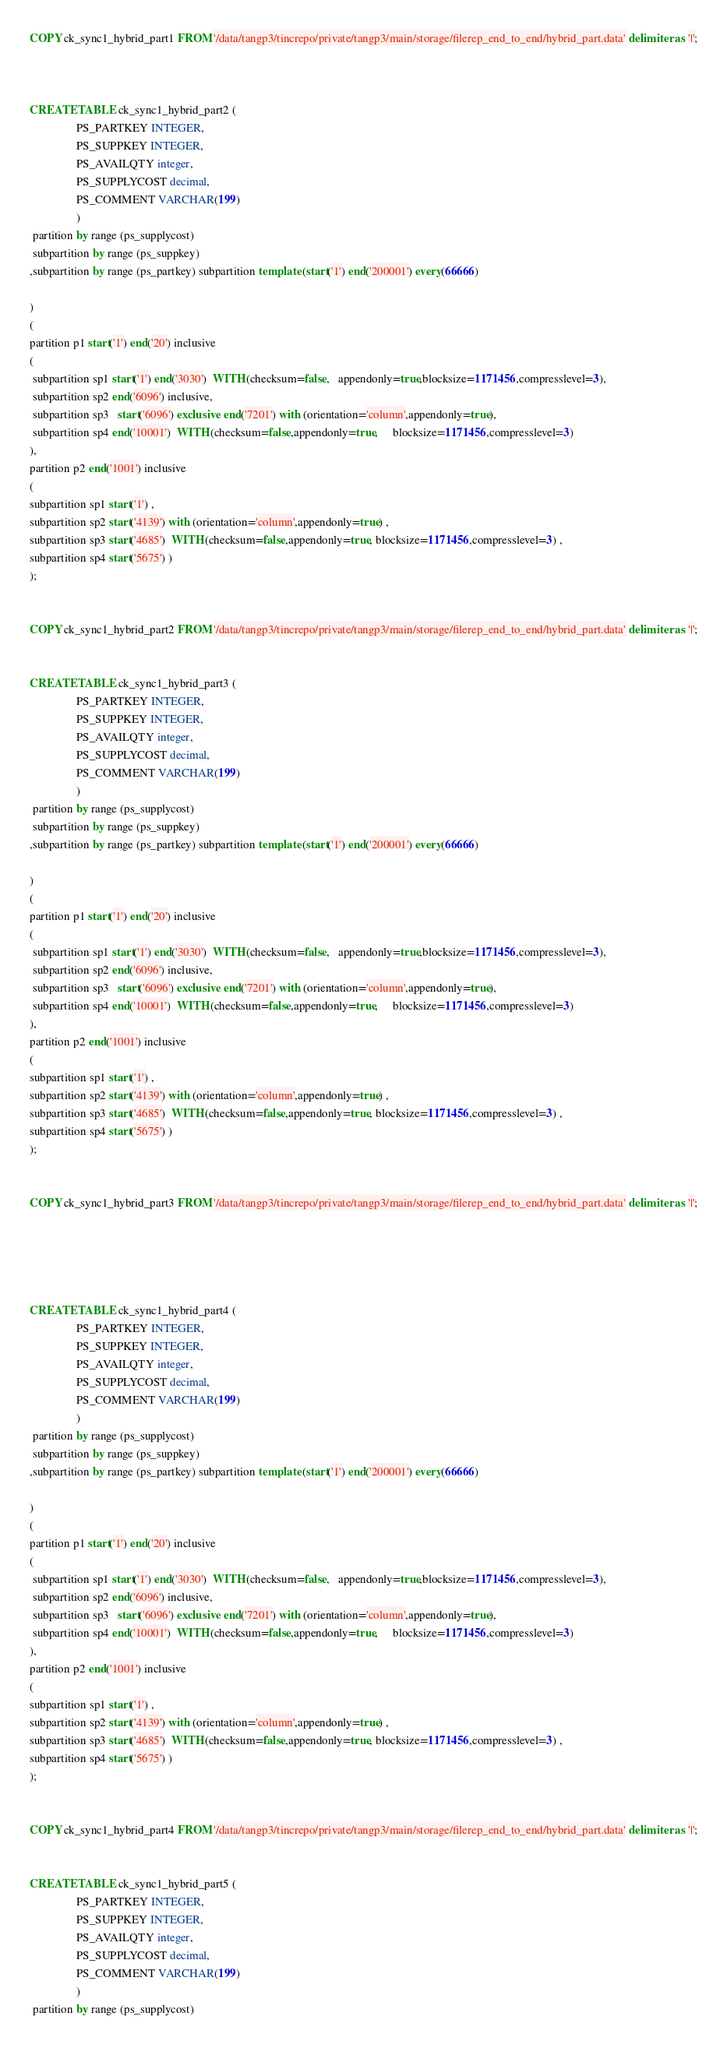<code> <loc_0><loc_0><loc_500><loc_500><_SQL_>
COPY ck_sync1_hybrid_part1 FROM '/data/tangp3/tincrepo/private/tangp3/main/storage/filerep_end_to_end/hybrid_part.data' delimiter as '|';



CREATE TABLE ck_sync1_hybrid_part2 (
                PS_PARTKEY INTEGER,
                PS_SUPPKEY INTEGER,
                PS_AVAILQTY integer,
                PS_SUPPLYCOST decimal,
                PS_COMMENT VARCHAR(199)
                ) 
 partition by range (ps_supplycost)
 subpartition by range (ps_suppkey)
,subpartition by range (ps_partkey) subpartition template (start('1') end('200001') every(66666)

)
(
partition p1 start('1') end('20') inclusive
(
 subpartition sp1 start('1') end('3030')  WITH (checksum=false,   appendonly=true,blocksize=1171456,compresslevel=3),
 subpartition sp2 end('6096') inclusive,
 subpartition sp3   start('6096') exclusive end('7201') with (orientation='column',appendonly=true),
 subpartition sp4 end('10001')  WITH (checksum=false,appendonly=true,     blocksize=1171456,compresslevel=3)
), 
partition p2 end('1001') inclusive
(
subpartition sp1 start('1') ,        
subpartition sp2 start('4139') with (orientation='column',appendonly=true) ,
subpartition sp3 start('4685')  WITH (checksum=false,appendonly=true, blocksize=1171456,compresslevel=3) ,
subpartition sp4 start('5675') )
);


COPY ck_sync1_hybrid_part2 FROM '/data/tangp3/tincrepo/private/tangp3/main/storage/filerep_end_to_end/hybrid_part.data' delimiter as '|';


CREATE TABLE ck_sync1_hybrid_part3 (
                PS_PARTKEY INTEGER,
                PS_SUPPKEY INTEGER,
                PS_AVAILQTY integer,
                PS_SUPPLYCOST decimal,
                PS_COMMENT VARCHAR(199)
                ) 
 partition by range (ps_supplycost)
 subpartition by range (ps_suppkey)
,subpartition by range (ps_partkey) subpartition template (start('1') end('200001') every(66666)

)
(
partition p1 start('1') end('20') inclusive
(
 subpartition sp1 start('1') end('3030')  WITH (checksum=false,   appendonly=true,blocksize=1171456,compresslevel=3),
 subpartition sp2 end('6096') inclusive,
 subpartition sp3   start('6096') exclusive end('7201') with (orientation='column',appendonly=true),
 subpartition sp4 end('10001')  WITH (checksum=false,appendonly=true,     blocksize=1171456,compresslevel=3)
), 
partition p2 end('1001') inclusive
(
subpartition sp1 start('1') ,        
subpartition sp2 start('4139') with (orientation='column',appendonly=true) ,
subpartition sp3 start('4685')  WITH (checksum=false,appendonly=true, blocksize=1171456,compresslevel=3) ,
subpartition sp4 start('5675') )
);


COPY ck_sync1_hybrid_part3 FROM '/data/tangp3/tincrepo/private/tangp3/main/storage/filerep_end_to_end/hybrid_part.data' delimiter as '|';





CREATE TABLE ck_sync1_hybrid_part4 (
                PS_PARTKEY INTEGER,
                PS_SUPPKEY INTEGER,
                PS_AVAILQTY integer,
                PS_SUPPLYCOST decimal,
                PS_COMMENT VARCHAR(199)
                ) 
 partition by range (ps_supplycost)
 subpartition by range (ps_suppkey)
,subpartition by range (ps_partkey) subpartition template (start('1') end('200001') every(66666)

)
(
partition p1 start('1') end('20') inclusive
(
 subpartition sp1 start('1') end('3030')  WITH (checksum=false,   appendonly=true,blocksize=1171456,compresslevel=3),
 subpartition sp2 end('6096') inclusive,
 subpartition sp3   start('6096') exclusive end('7201') with (orientation='column',appendonly=true),
 subpartition sp4 end('10001')  WITH (checksum=false,appendonly=true,     blocksize=1171456,compresslevel=3)
), 
partition p2 end('1001') inclusive
(
subpartition sp1 start('1') ,        
subpartition sp2 start('4139') with (orientation='column',appendonly=true) ,
subpartition sp3 start('4685')  WITH (checksum=false,appendonly=true, blocksize=1171456,compresslevel=3) ,
subpartition sp4 start('5675') )
);


COPY ck_sync1_hybrid_part4 FROM '/data/tangp3/tincrepo/private/tangp3/main/storage/filerep_end_to_end/hybrid_part.data' delimiter as '|';


CREATE TABLE ck_sync1_hybrid_part5 (
                PS_PARTKEY INTEGER,
                PS_SUPPKEY INTEGER,
                PS_AVAILQTY integer,
                PS_SUPPLYCOST decimal,
                PS_COMMENT VARCHAR(199)
                ) 
 partition by range (ps_supplycost)</code> 